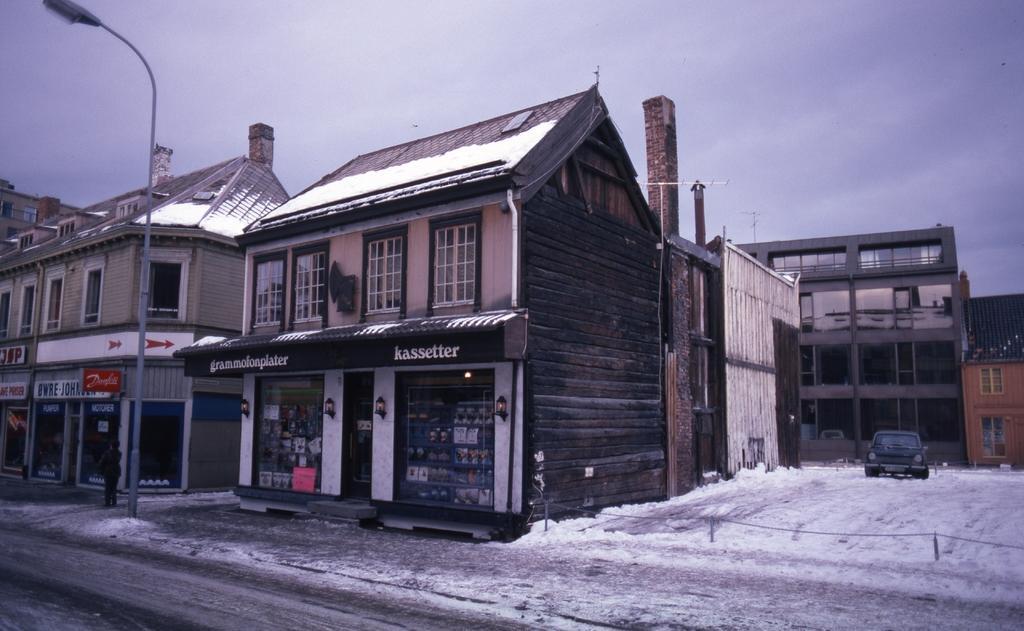How would you summarize this image in a sentence or two? In the center of the image we can see buildings, roof, windows, stores, boards, electric light pole, wall. On the right side of the image we can see car, barricades, snow. At the top of the image clouds are present in the sky. At the bottom of the image there is a road. On the left side of the image a person is there. 